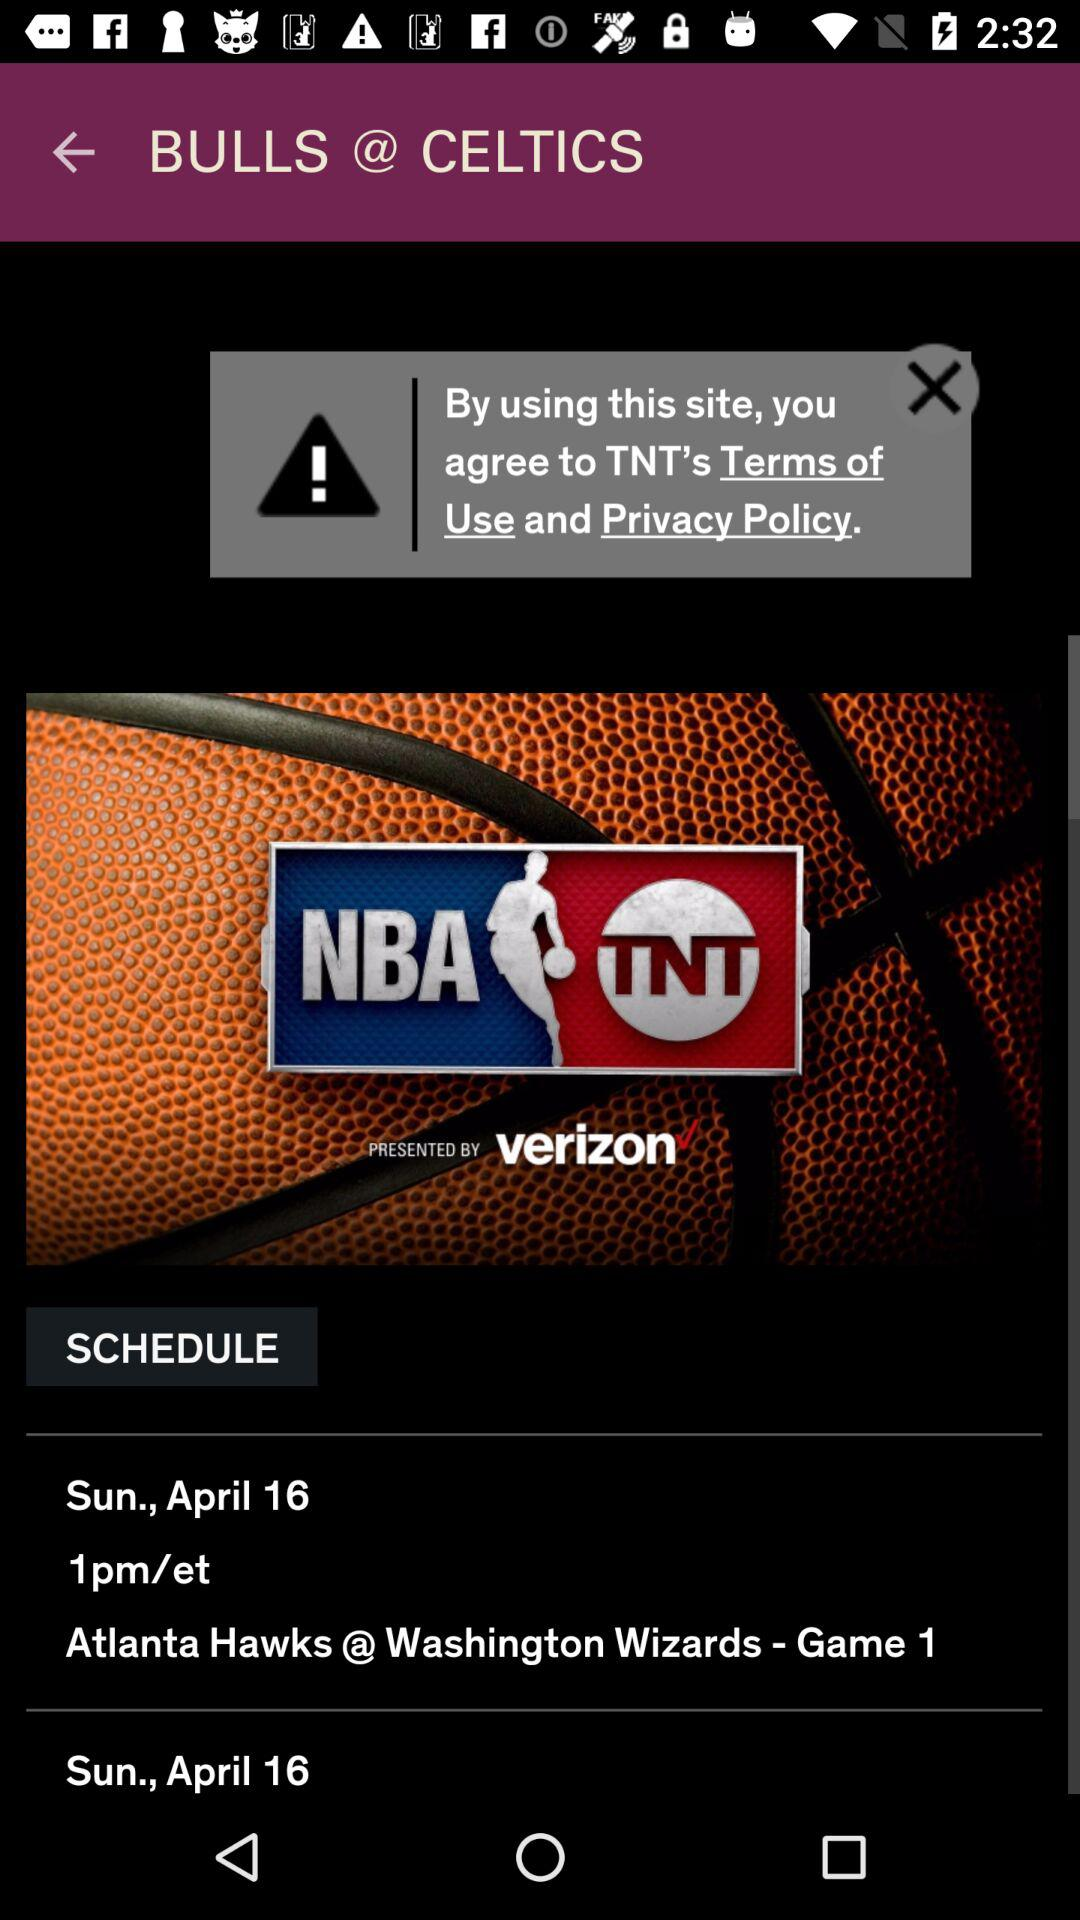What is the location?
When the provided information is insufficient, respond with <no answer>. <no answer> 